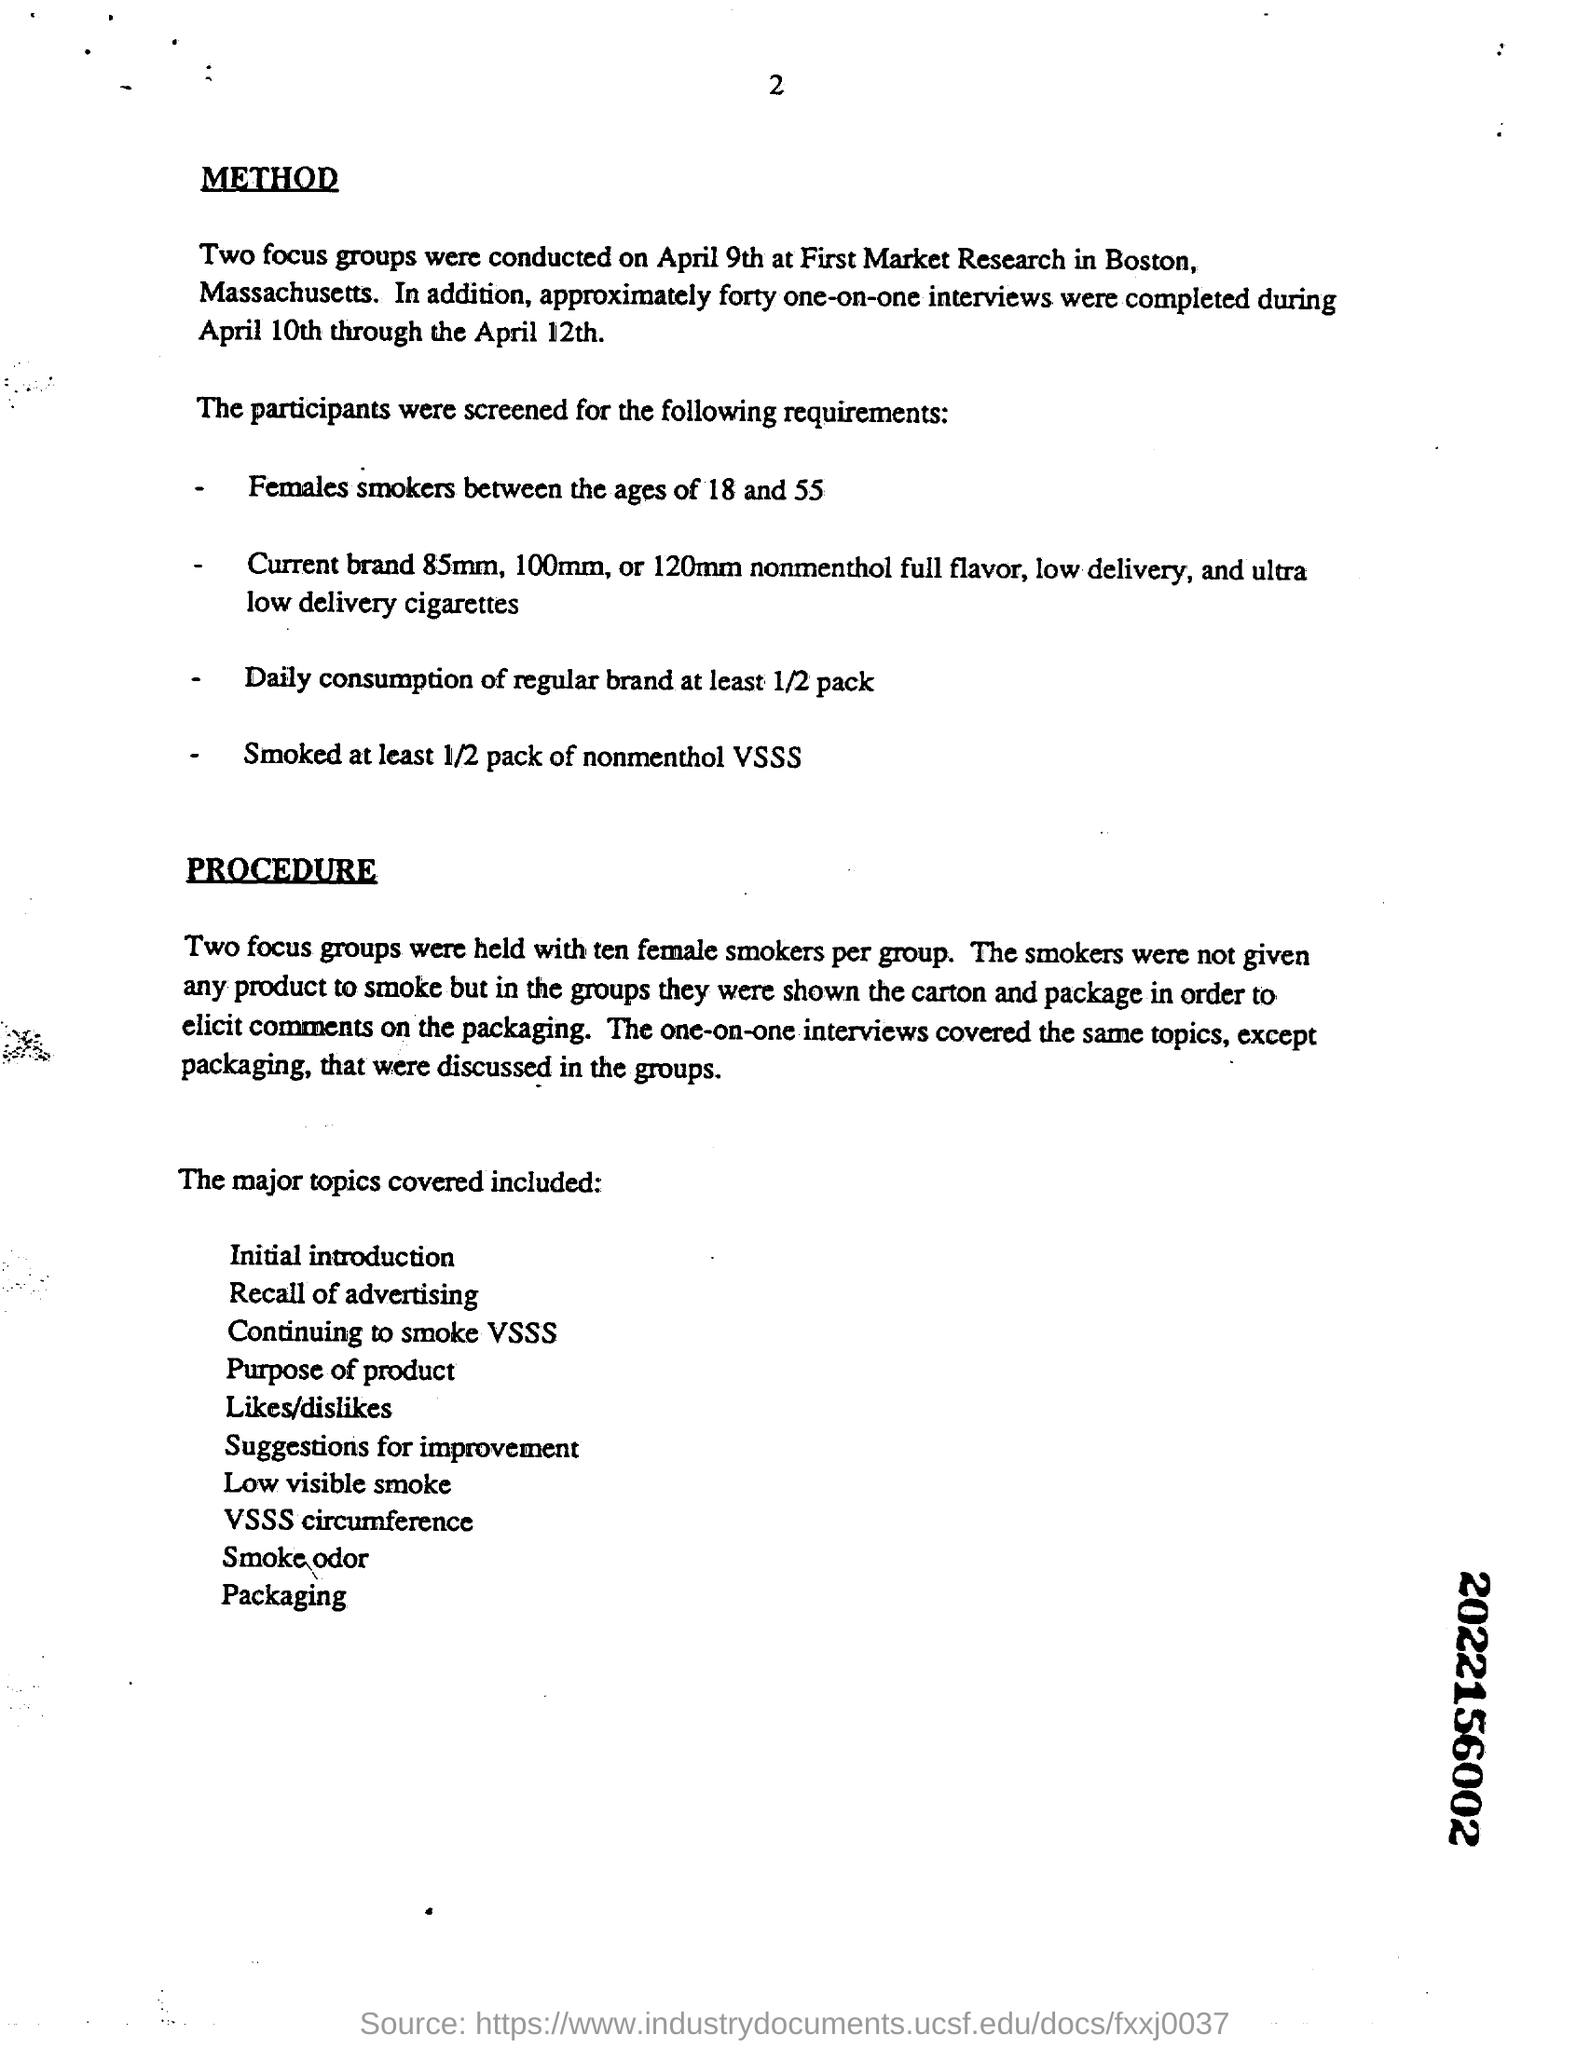Specify some key components in this picture. According to the requirements, a regular brand must consume at least 1/2 pack per use. Based on the listed requirements, it is necessary for female smokers to fall within the age range of 18 and 55 years old. Two focus groups were held. During April 10th through April 12th, a total of forty one-on-one interviews were completed. The one-on-one interviews covered the same topics as the group discussions, except for packaging. 